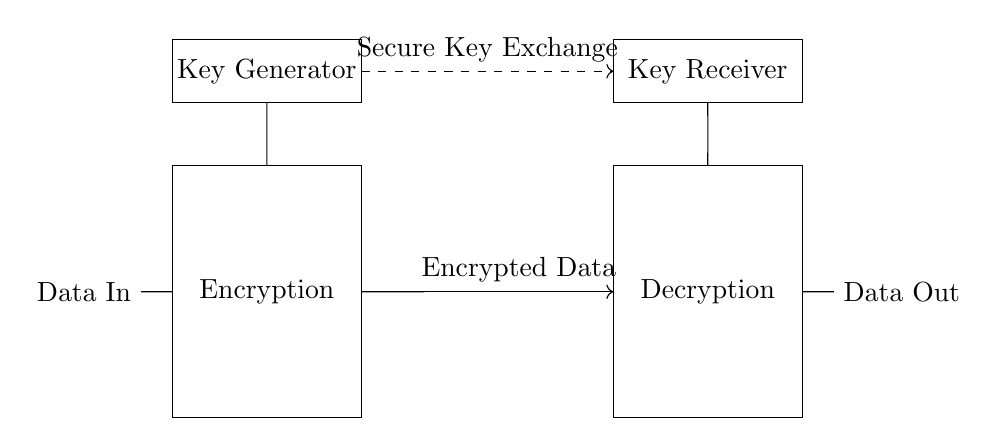What does the encryption block do? The encryption block is responsible for transforming the original data into an encrypted format, ensuring its confidentiality during transmission.
Answer: Encrypts data What is the function of the key generator? The key generator creates the cryptographic keys used for encrypting and decrypting the data, which is essential for maintaining secure communication.
Answer: Generates keys What is transmitted through the secure channel? The secure channel is used for exchanging cryptographic keys, ensuring they are protected from eavesdropping during the key distribution process.
Answer: Keys How many main components are in the circuit? There are four main components in the circuit: Data In, Encryption block, Decryption block, and Data Out.
Answer: Four Which component receives the encrypted data? The Decryption block is the component that receives the encrypted data for further processing to retrieve the original data.
Answer: Decryption What direction does the data flow from the encryption block? The data flows from the encryption block to the right toward the Decryption block as indicated by the arrows showing the direction of transmission.
Answer: Right What is the purpose of the dashed line in the circuit? The dashed line represents the secure channel for key exchange, indicating that this pathway is crucial for securely transmitting the keys between the sender and receiver.
Answer: Key exchange 